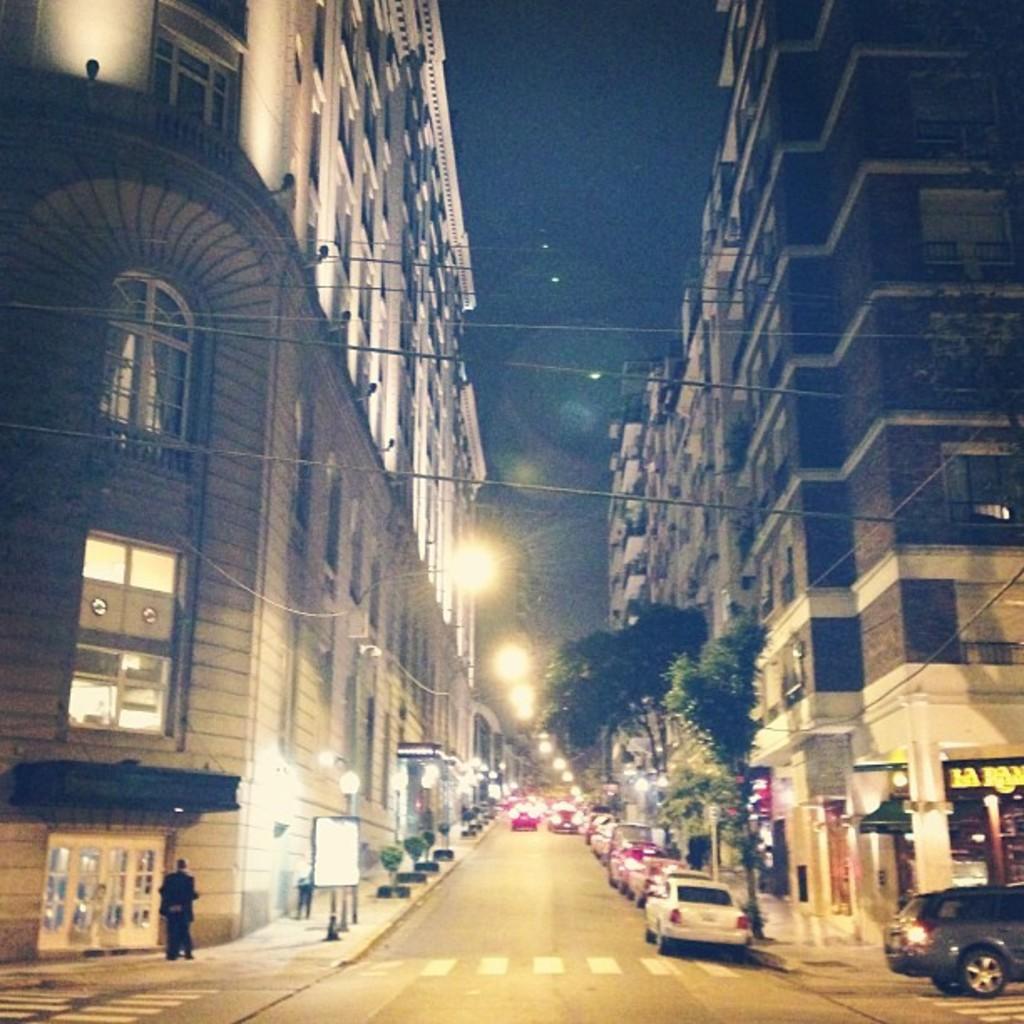Describe this image in one or two sentences. In this image we can see some buildings, some lights with poles, some lights, on board with pole, some objects attached to the buildings, some trees, some objects on the ground, some objects in the buildings, two person´s walking on the footpath, some vehicles on the road, some text on the building on the right side of the image, some wires, at the top there is the sky, the background is dark and blurred. 